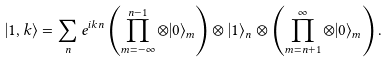<formula> <loc_0><loc_0><loc_500><loc_500>| 1 , k \rangle = \sum _ { n } e ^ { i k n } \left ( \prod _ { m = - \infty } ^ { n - 1 } \otimes | 0 \rangle _ { m } \right ) \otimes | 1 \rangle _ { n } \otimes \left ( \prod _ { m = n + 1 } ^ { \infty } \otimes | 0 \rangle _ { m } \right ) .</formula> 